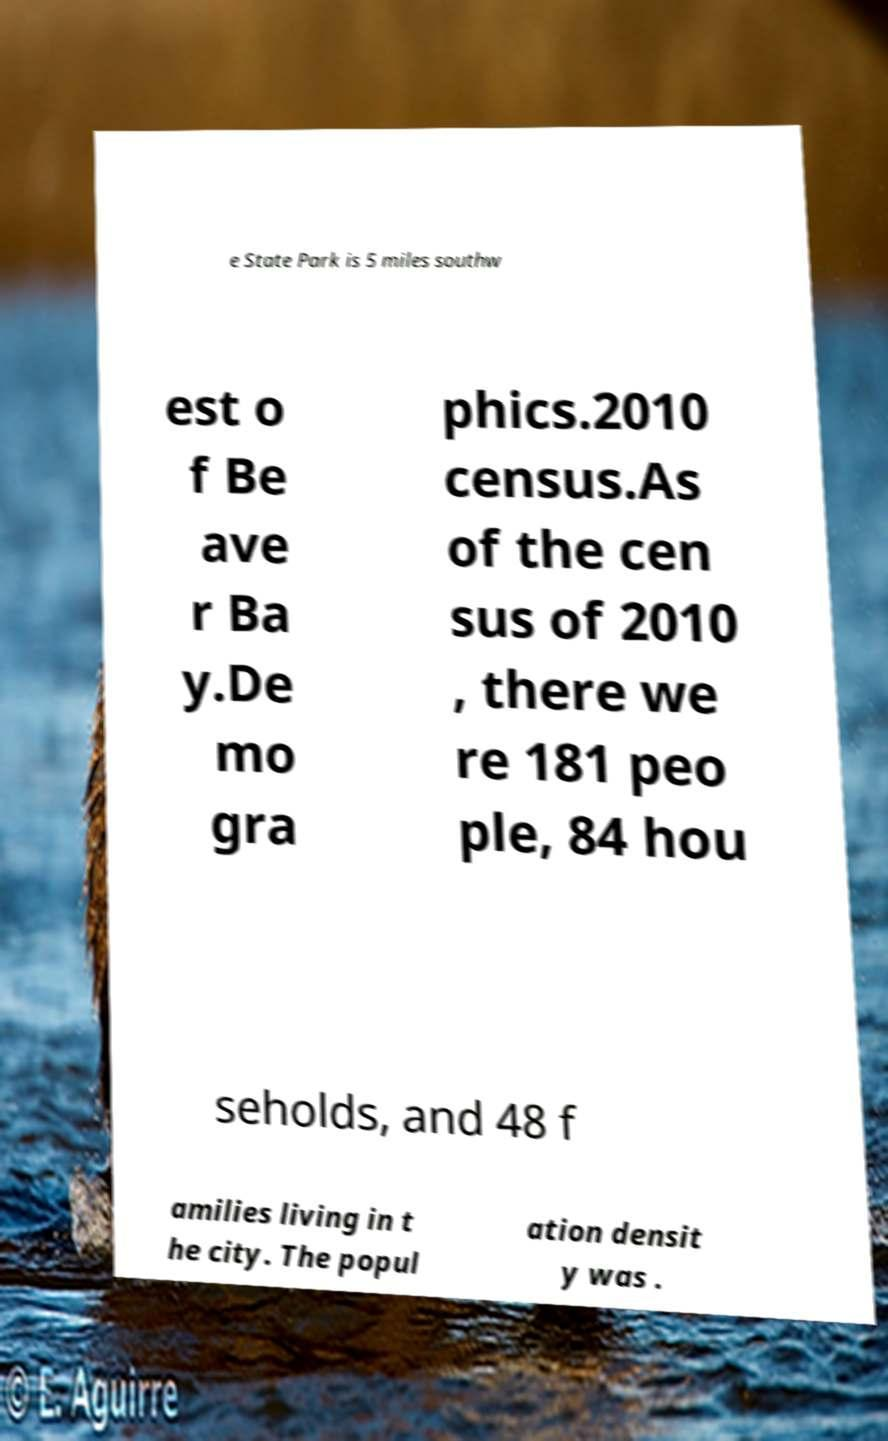Please identify and transcribe the text found in this image. e State Park is 5 miles southw est o f Be ave r Ba y.De mo gra phics.2010 census.As of the cen sus of 2010 , there we re 181 peo ple, 84 hou seholds, and 48 f amilies living in t he city. The popul ation densit y was . 